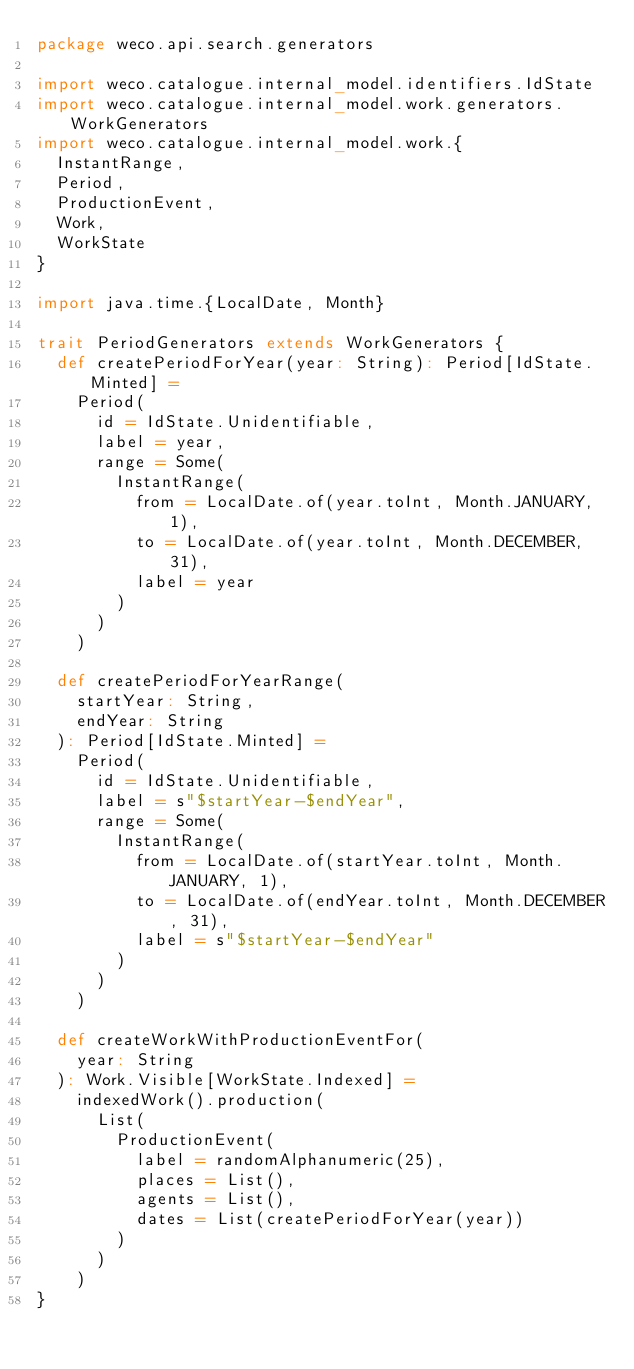<code> <loc_0><loc_0><loc_500><loc_500><_Scala_>package weco.api.search.generators

import weco.catalogue.internal_model.identifiers.IdState
import weco.catalogue.internal_model.work.generators.WorkGenerators
import weco.catalogue.internal_model.work.{
  InstantRange,
  Period,
  ProductionEvent,
  Work,
  WorkState
}

import java.time.{LocalDate, Month}

trait PeriodGenerators extends WorkGenerators {
  def createPeriodForYear(year: String): Period[IdState.Minted] =
    Period(
      id = IdState.Unidentifiable,
      label = year,
      range = Some(
        InstantRange(
          from = LocalDate.of(year.toInt, Month.JANUARY, 1),
          to = LocalDate.of(year.toInt, Month.DECEMBER, 31),
          label = year
        )
      )
    )

  def createPeriodForYearRange(
    startYear: String,
    endYear: String
  ): Period[IdState.Minted] =
    Period(
      id = IdState.Unidentifiable,
      label = s"$startYear-$endYear",
      range = Some(
        InstantRange(
          from = LocalDate.of(startYear.toInt, Month.JANUARY, 1),
          to = LocalDate.of(endYear.toInt, Month.DECEMBER, 31),
          label = s"$startYear-$endYear"
        )
      )
    )

  def createWorkWithProductionEventFor(
    year: String
  ): Work.Visible[WorkState.Indexed] =
    indexedWork().production(
      List(
        ProductionEvent(
          label = randomAlphanumeric(25),
          places = List(),
          agents = List(),
          dates = List(createPeriodForYear(year))
        )
      )
    )
}
</code> 